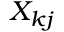Convert formula to latex. <formula><loc_0><loc_0><loc_500><loc_500>X _ { k j }</formula> 